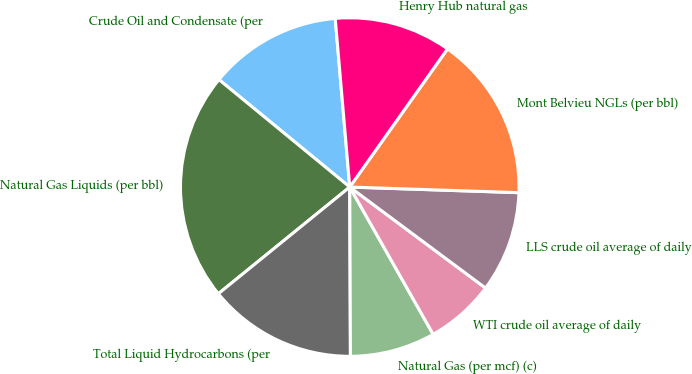<chart> <loc_0><loc_0><loc_500><loc_500><pie_chart><fcel>Crude Oil and Condensate (per<fcel>Natural Gas Liquids (per bbl)<fcel>Total Liquid Hydrocarbons (per<fcel>Natural Gas (per mcf) (c)<fcel>WTI crude oil average of daily<fcel>LLS crude oil average of daily<fcel>Mont Belvieu NGLs (per bbl)<fcel>Henry Hub natural gas<nl><fcel>12.69%<fcel>21.8%<fcel>14.21%<fcel>8.14%<fcel>6.62%<fcel>9.65%<fcel>15.73%<fcel>11.17%<nl></chart> 